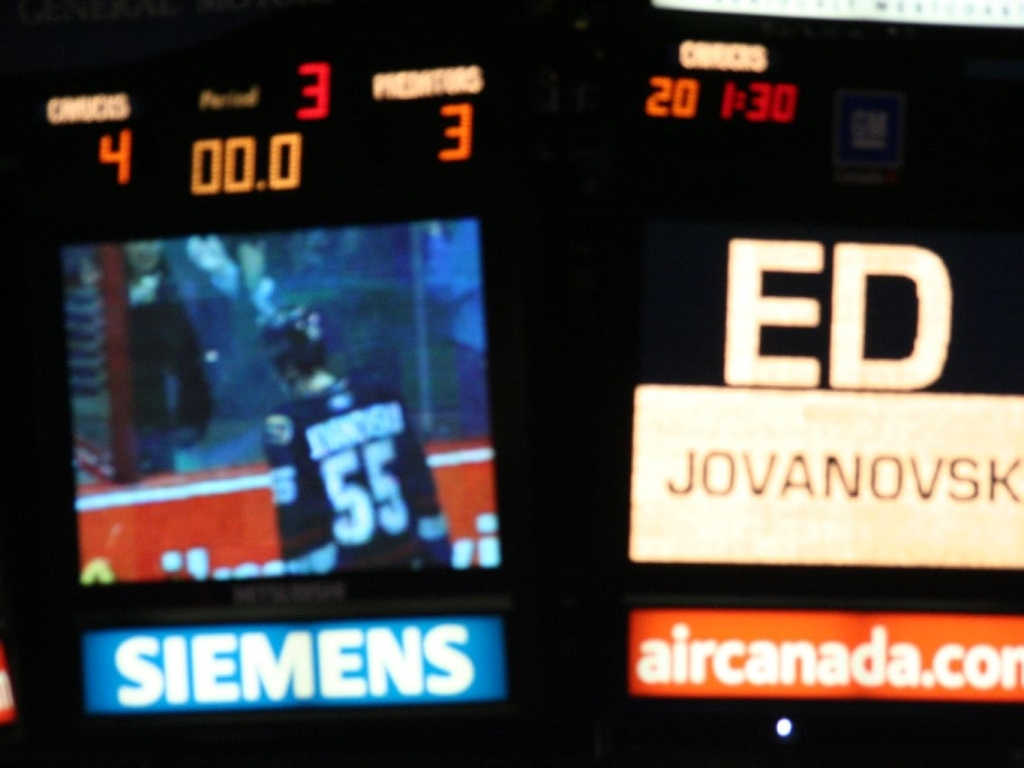What might be some reasons for the image's lack of sharpness? Several factors could contribute to the image's lack of sharpness. It could be due to a slow shutter speed that wasn't sufficient to freeze the motion of the game, resulting in motion blur. Camera shake is another possibility if the photograph was taken handheld without stabilization. Additionally, if the focus wasn't set correctly, the main subject would appear blurred. Lastly, a high ISO setting might have been used in a low-light environment, leading to a grainier, less sharp image. 